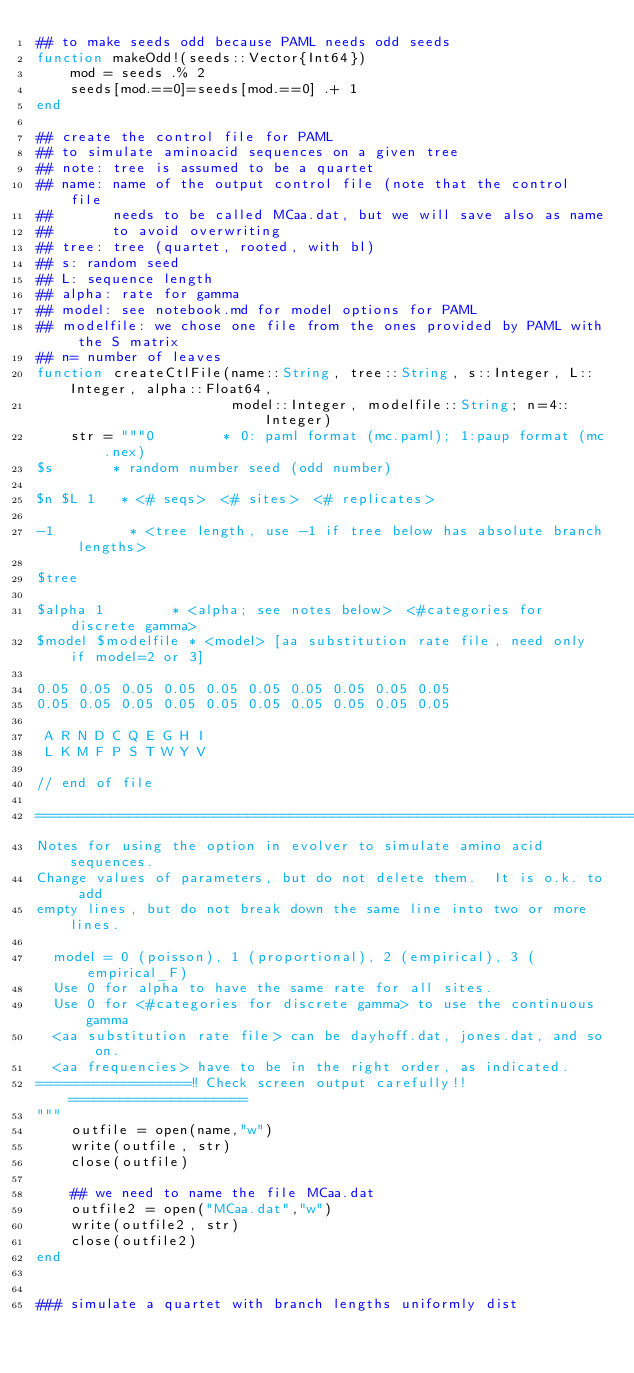<code> <loc_0><loc_0><loc_500><loc_500><_Julia_>## to make seeds odd because PAML needs odd seeds
function makeOdd!(seeds::Vector{Int64})
    mod = seeds .% 2
    seeds[mod.==0]=seeds[mod.==0] .+ 1
end

## create the control file for PAML
## to simulate aminoacid sequences on a given tree
## note: tree is assumed to be a quartet
## name: name of the output control file (note that the control file
##       needs to be called MCaa.dat, but we will save also as name
##       to avoid overwriting
## tree: tree (quartet, rooted, with bl)
## s: random seed
## L: sequence length
## alpha: rate for gamma
## model: see notebook.md for model options for PAML
## modelfile: we chose one file from the ones provided by PAML with the S matrix
## n= number of leaves
function createCtlFile(name::String, tree::String, s::Integer, L::Integer, alpha::Float64,
                       model::Integer, modelfile::String; n=4::Integer)
    str = """0        * 0: paml format (mc.paml); 1:paup format (mc.nex)
$s       * random number seed (odd number)

$n $L 1   * <# seqs>  <# sites>  <# replicates>

-1         * <tree length, use -1 if tree below has absolute branch lengths>

$tree

$alpha 1        * <alpha; see notes below>  <#categories for discrete gamma>
$model $modelfile * <model> [aa substitution rate file, need only if model=2 or 3]

0.05 0.05 0.05 0.05 0.05 0.05 0.05 0.05 0.05 0.05
0.05 0.05 0.05 0.05 0.05 0.05 0.05 0.05 0.05 0.05

 A R N D C Q E G H I
 L K M F P S T W Y V

// end of file

=============================================================================
Notes for using the option in evolver to simulate amino acid sequences.
Change values of parameters, but do not delete them.  It is o.k. to add
empty lines, but do not break down the same line into two or more lines.

  model = 0 (poisson), 1 (proportional), 2 (empirical), 3 (empirical_F)
  Use 0 for alpha to have the same rate for all sites.
  Use 0 for <#categories for discrete gamma> to use the continuous gamma
  <aa substitution rate file> can be dayhoff.dat, jones.dat, and so on.
  <aa frequencies> have to be in the right order, as indicated.
=================!! Check screen output carefully!! =====================
"""
    outfile = open(name,"w")
    write(outfile, str)
    close(outfile)

    ## we need to name the file MCaa.dat
    outfile2 = open("MCaa.dat","w")
    write(outfile2, str)
    close(outfile2)
end


### simulate a quartet with branch lengths uniformly dist</code> 